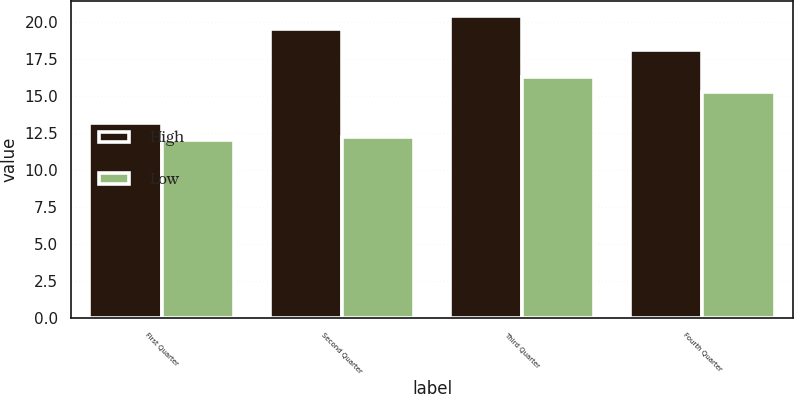Convert chart to OTSL. <chart><loc_0><loc_0><loc_500><loc_500><stacked_bar_chart><ecel><fcel>First Quarter<fcel>Second Quarter<fcel>Third Quarter<fcel>Fourth Quarter<nl><fcel>High<fcel>13.19<fcel>19.5<fcel>20.4<fcel>18.06<nl><fcel>Low<fcel>12.02<fcel>12.24<fcel>16.25<fcel>15.22<nl></chart> 